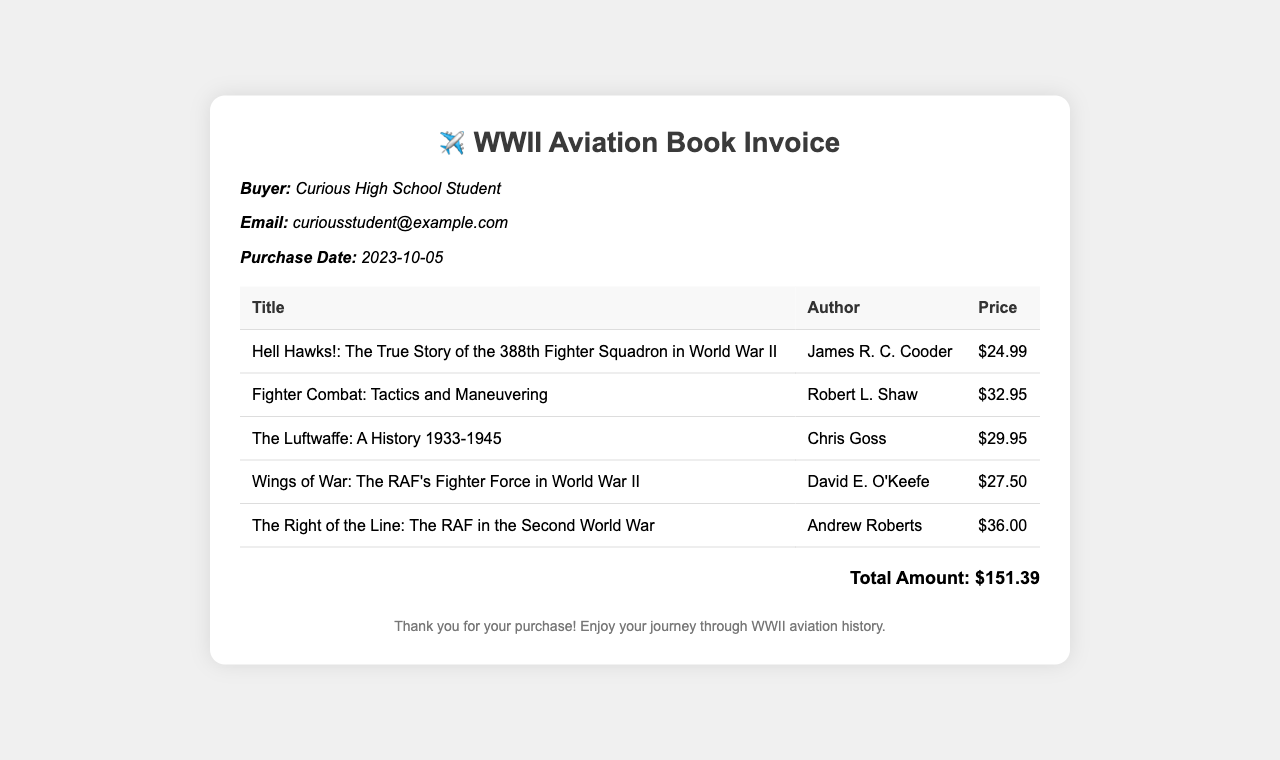What is the buyer's name? The buyer's name is listed in the document under "Buyer" and is "Curious High School Student."
Answer: Curious High School Student What is the purchase date? The purchase date is mentioned in the buyer's information section and is "2023-10-05."
Answer: 2023-10-05 Who is the author of "Fighter Combat: Tactics and Maneuvering"? The author of this book is mentioned in the table of titles and is "Robert L. Shaw."
Answer: Robert L. Shaw What is the price of "The Luftwaffe: A History 1933-1945"? The price is recorded in the table where this book is listed, which shows it as "$29.95."
Answer: $29.95 What is the total amount for the purchased books? The total amount is detailed at the bottom of the document and is "$151.39."
Answer: $151.39 How many books are listed in the invoice? The invoice contains a table with five separate books listed.
Answer: 5 What is the title of the most expensive book? The title of the most expensive book is included in the table and is "The Right of the Line: The RAF in the Second World War" priced at "$36.00."
Answer: The Right of the Line: The RAF in the Second World War What is the main focus of the books listed in the invoice? The main focus is implied through the titles and authors of the books, which center around World War II aviation.
Answer: World War II aviation 